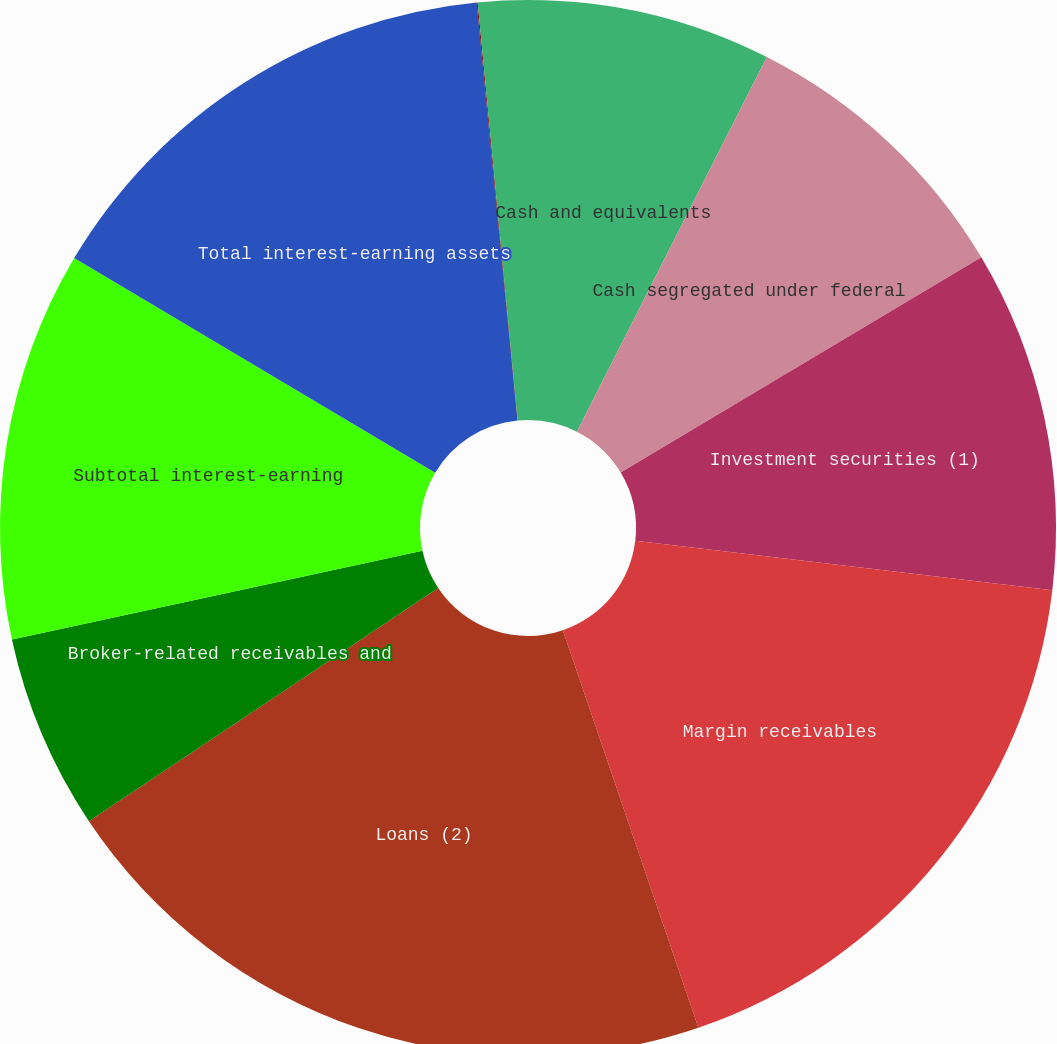<chart> <loc_0><loc_0><loc_500><loc_500><pie_chart><fcel>Cash and equivalents<fcel>Cash segregated under federal<fcel>Investment securities (1)<fcel>Margin receivables<fcel>Loans (2)<fcel>Broker-related receivables and<fcel>Subtotal interest-earning<fcel>Total interest-earning assets<fcel>Sweep deposits<fcel>Customer payables<nl><fcel>7.47%<fcel>8.96%<fcel>10.45%<fcel>17.89%<fcel>20.86%<fcel>5.98%<fcel>11.93%<fcel>14.91%<fcel>0.03%<fcel>1.52%<nl></chart> 